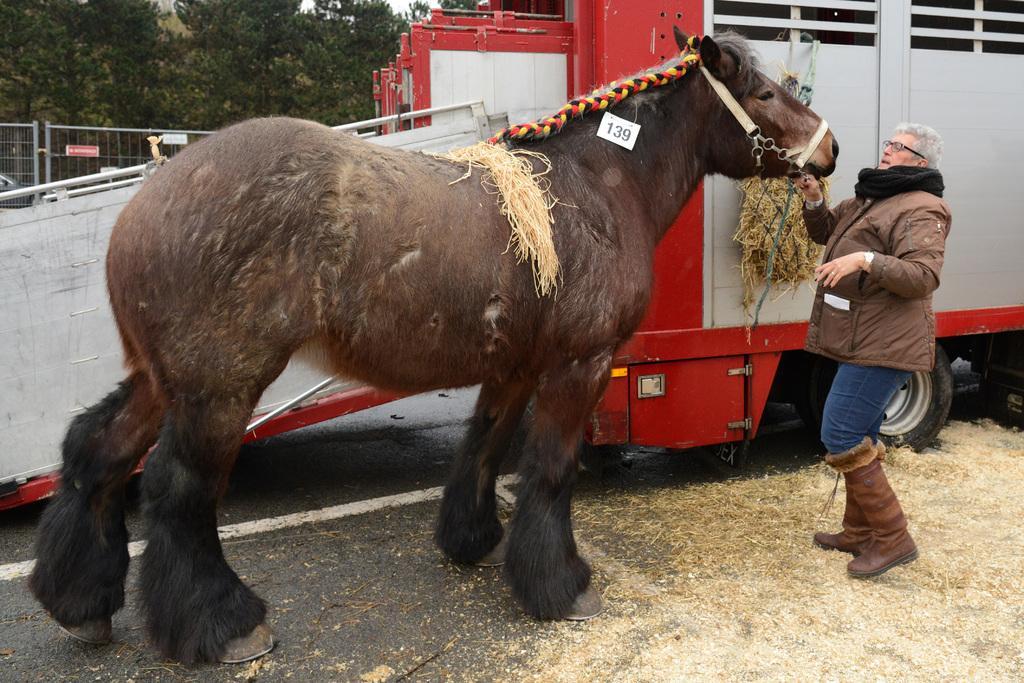In one or two sentences, can you explain what this image depicts? In this image we can see a person holding the horse and at the back side there is a vehicle and at the background there are trees. 